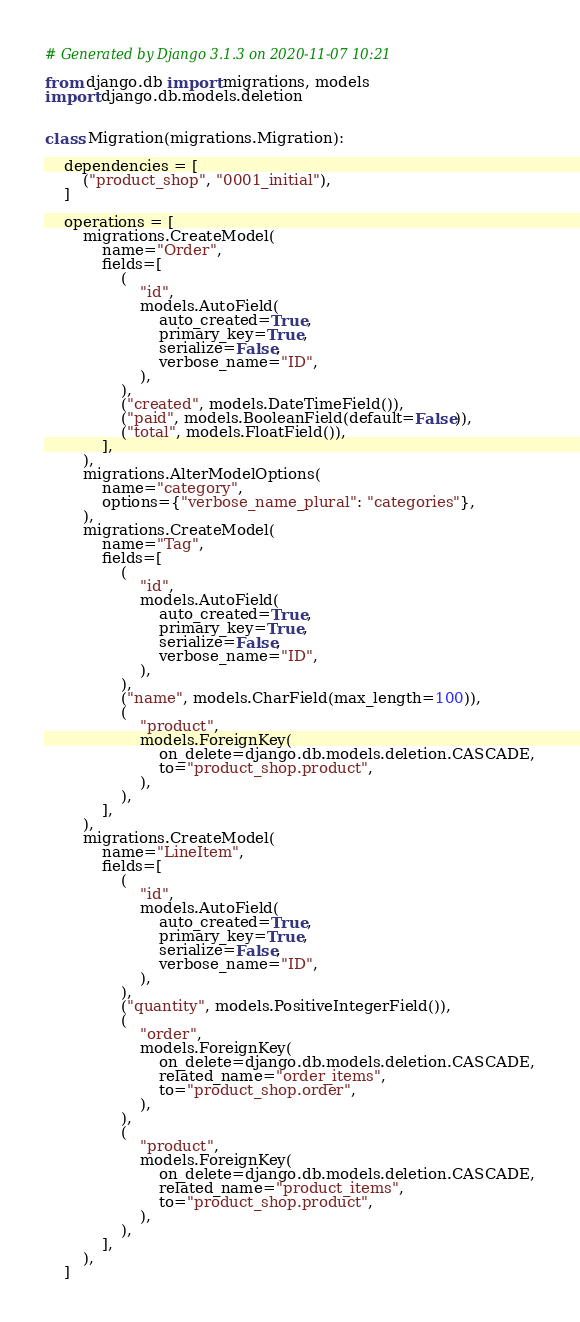<code> <loc_0><loc_0><loc_500><loc_500><_Python_># Generated by Django 3.1.3 on 2020-11-07 10:21

from django.db import migrations, models
import django.db.models.deletion


class Migration(migrations.Migration):

    dependencies = [
        ("product_shop", "0001_initial"),
    ]

    operations = [
        migrations.CreateModel(
            name="Order",
            fields=[
                (
                    "id",
                    models.AutoField(
                        auto_created=True,
                        primary_key=True,
                        serialize=False,
                        verbose_name="ID",
                    ),
                ),
                ("created", models.DateTimeField()),
                ("paid", models.BooleanField(default=False)),
                ("total", models.FloatField()),
            ],
        ),
        migrations.AlterModelOptions(
            name="category",
            options={"verbose_name_plural": "categories"},
        ),
        migrations.CreateModel(
            name="Tag",
            fields=[
                (
                    "id",
                    models.AutoField(
                        auto_created=True,
                        primary_key=True,
                        serialize=False,
                        verbose_name="ID",
                    ),
                ),
                ("name", models.CharField(max_length=100)),
                (
                    "product",
                    models.ForeignKey(
                        on_delete=django.db.models.deletion.CASCADE,
                        to="product_shop.product",
                    ),
                ),
            ],
        ),
        migrations.CreateModel(
            name="LineItem",
            fields=[
                (
                    "id",
                    models.AutoField(
                        auto_created=True,
                        primary_key=True,
                        serialize=False,
                        verbose_name="ID",
                    ),
                ),
                ("quantity", models.PositiveIntegerField()),
                (
                    "order",
                    models.ForeignKey(
                        on_delete=django.db.models.deletion.CASCADE,
                        related_name="order_items",
                        to="product_shop.order",
                    ),
                ),
                (
                    "product",
                    models.ForeignKey(
                        on_delete=django.db.models.deletion.CASCADE,
                        related_name="product_items",
                        to="product_shop.product",
                    ),
                ),
            ],
        ),
    ]
</code> 